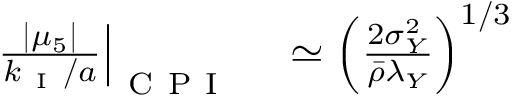<formula> <loc_0><loc_0><loc_500><loc_500>\begin{array} { r l } { \frac { | \mu _ { 5 } | } { k _ { I } / a } \right | _ { C P I } } & \simeq \left ( \frac { 2 \sigma _ { Y } ^ { 2 } } { \bar { \rho } \lambda _ { Y } } \right ) ^ { 1 / 3 } } \end{array}</formula> 